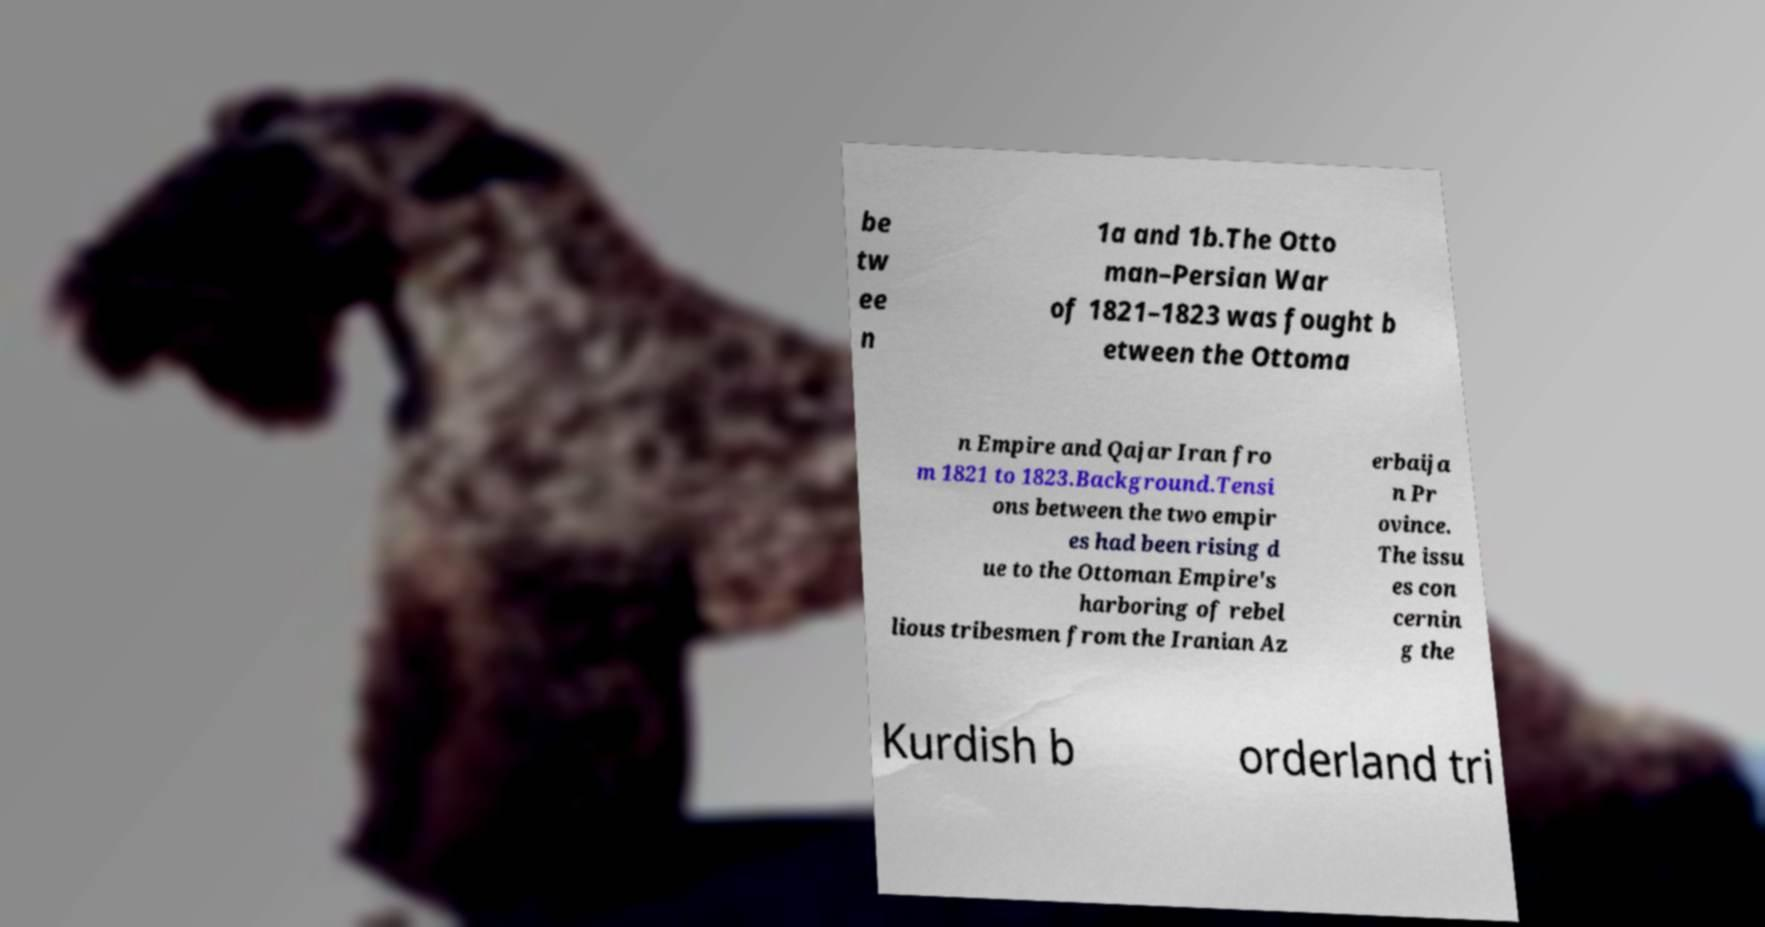Please read and relay the text visible in this image. What does it say? be tw ee n 1a and 1b.The Otto man–Persian War of 1821–1823 was fought b etween the Ottoma n Empire and Qajar Iran fro m 1821 to 1823.Background.Tensi ons between the two empir es had been rising d ue to the Ottoman Empire's harboring of rebel lious tribesmen from the Iranian Az erbaija n Pr ovince. The issu es con cernin g the Kurdish b orderland tri 